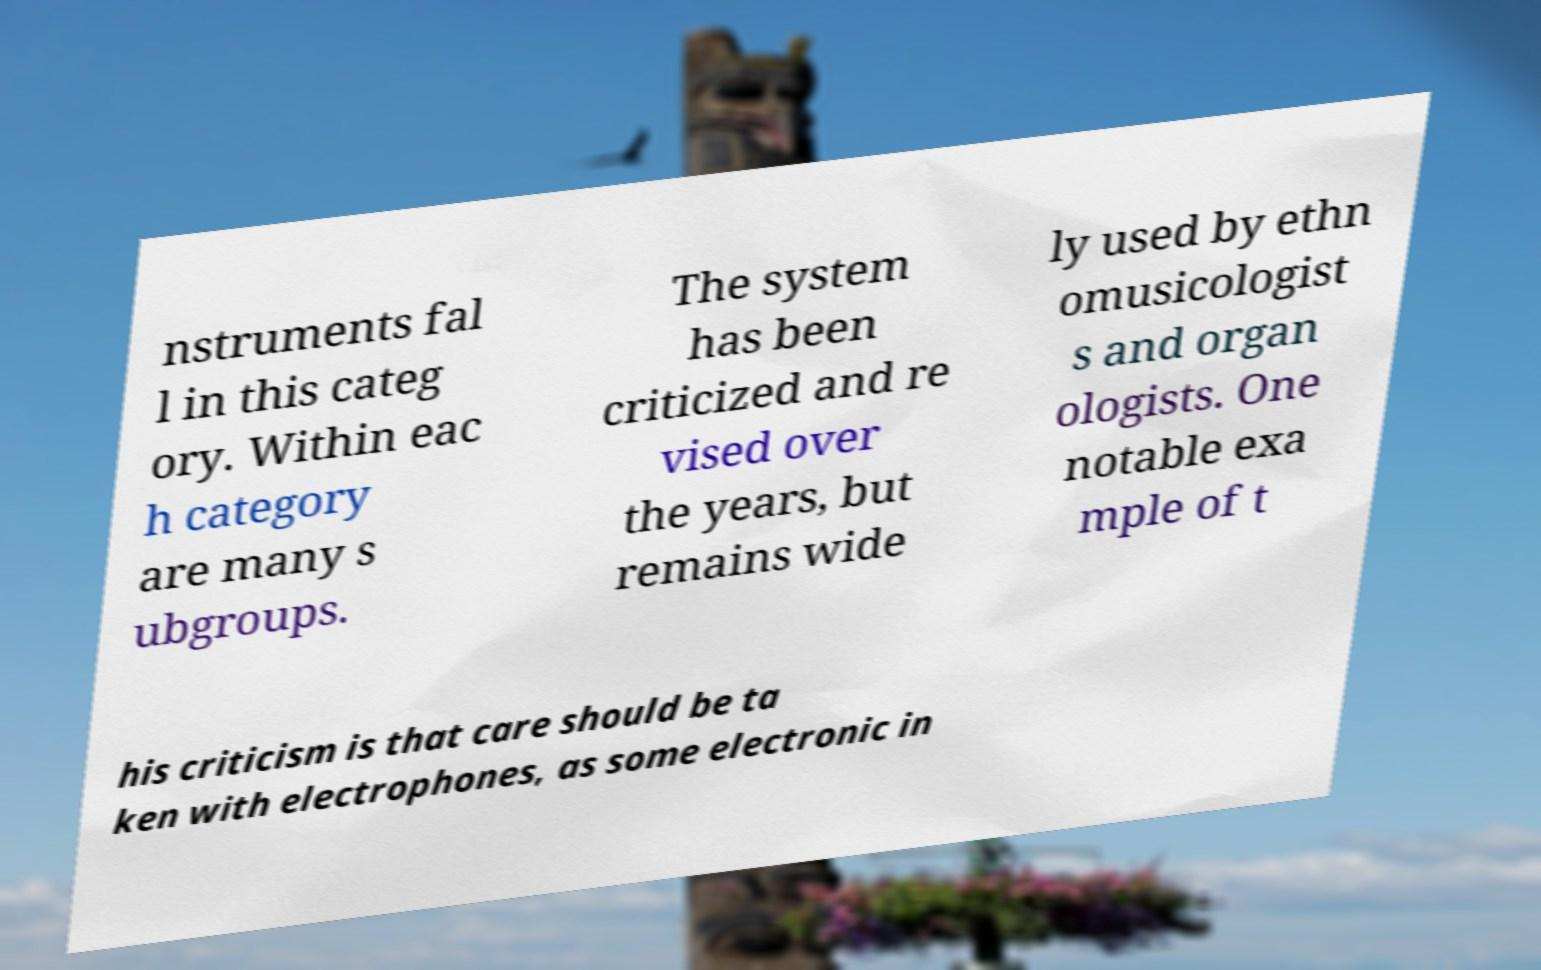Can you accurately transcribe the text from the provided image for me? nstruments fal l in this categ ory. Within eac h category are many s ubgroups. The system has been criticized and re vised over the years, but remains wide ly used by ethn omusicologist s and organ ologists. One notable exa mple of t his criticism is that care should be ta ken with electrophones, as some electronic in 